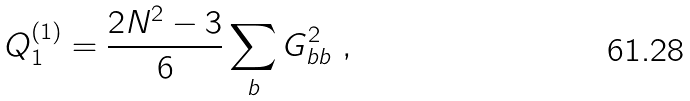<formula> <loc_0><loc_0><loc_500><loc_500>Q _ { 1 } ^ { ( 1 ) } = \frac { 2 N ^ { 2 } - 3 } { 6 } \sum _ { b } G ^ { 2 } _ { b b } \ ,</formula> 